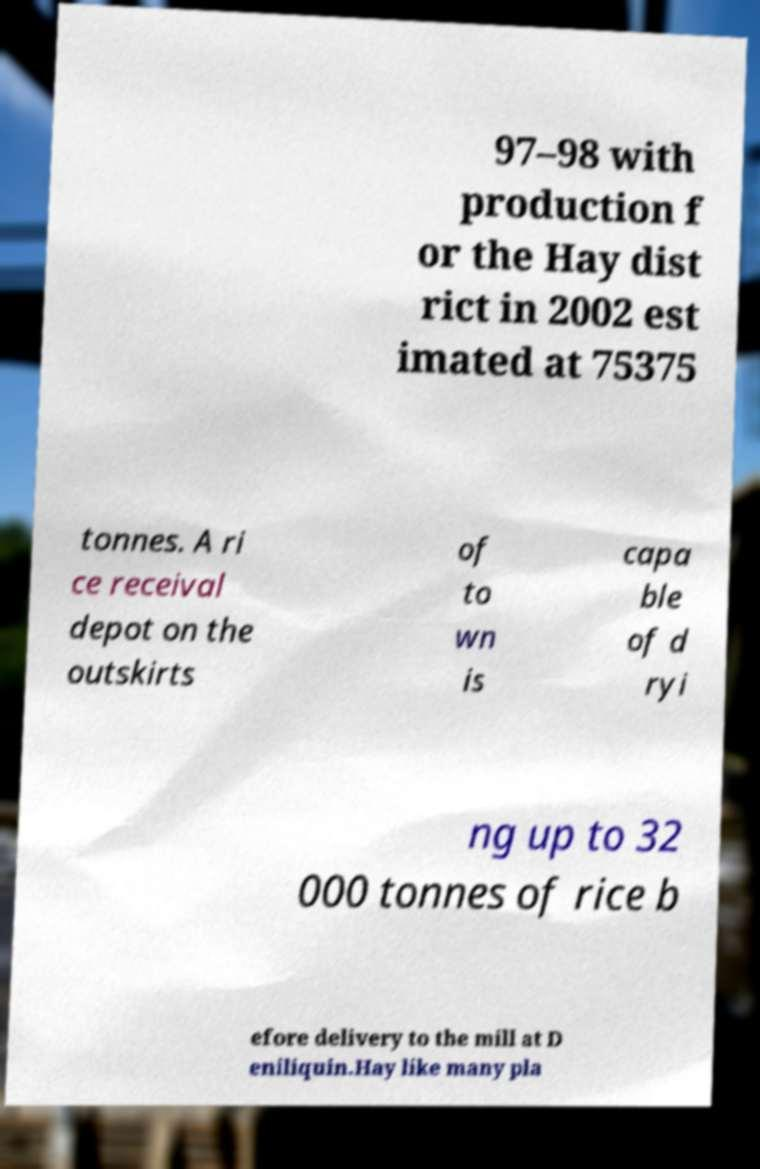Can you accurately transcribe the text from the provided image for me? 97–98 with production f or the Hay dist rict in 2002 est imated at 75375 tonnes. A ri ce receival depot on the outskirts of to wn is capa ble of d ryi ng up to 32 000 tonnes of rice b efore delivery to the mill at D eniliquin.Hay like many pla 